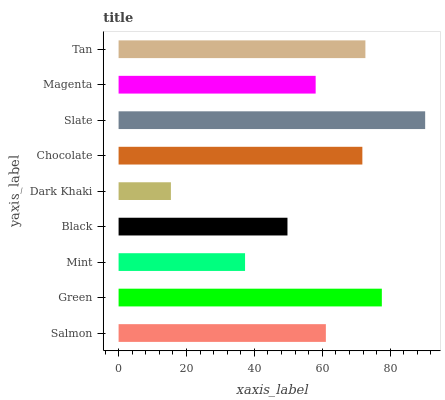Is Dark Khaki the minimum?
Answer yes or no. Yes. Is Slate the maximum?
Answer yes or no. Yes. Is Green the minimum?
Answer yes or no. No. Is Green the maximum?
Answer yes or no. No. Is Green greater than Salmon?
Answer yes or no. Yes. Is Salmon less than Green?
Answer yes or no. Yes. Is Salmon greater than Green?
Answer yes or no. No. Is Green less than Salmon?
Answer yes or no. No. Is Salmon the high median?
Answer yes or no. Yes. Is Salmon the low median?
Answer yes or no. Yes. Is Slate the high median?
Answer yes or no. No. Is Mint the low median?
Answer yes or no. No. 